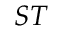Convert formula to latex. <formula><loc_0><loc_0><loc_500><loc_500>S T</formula> 